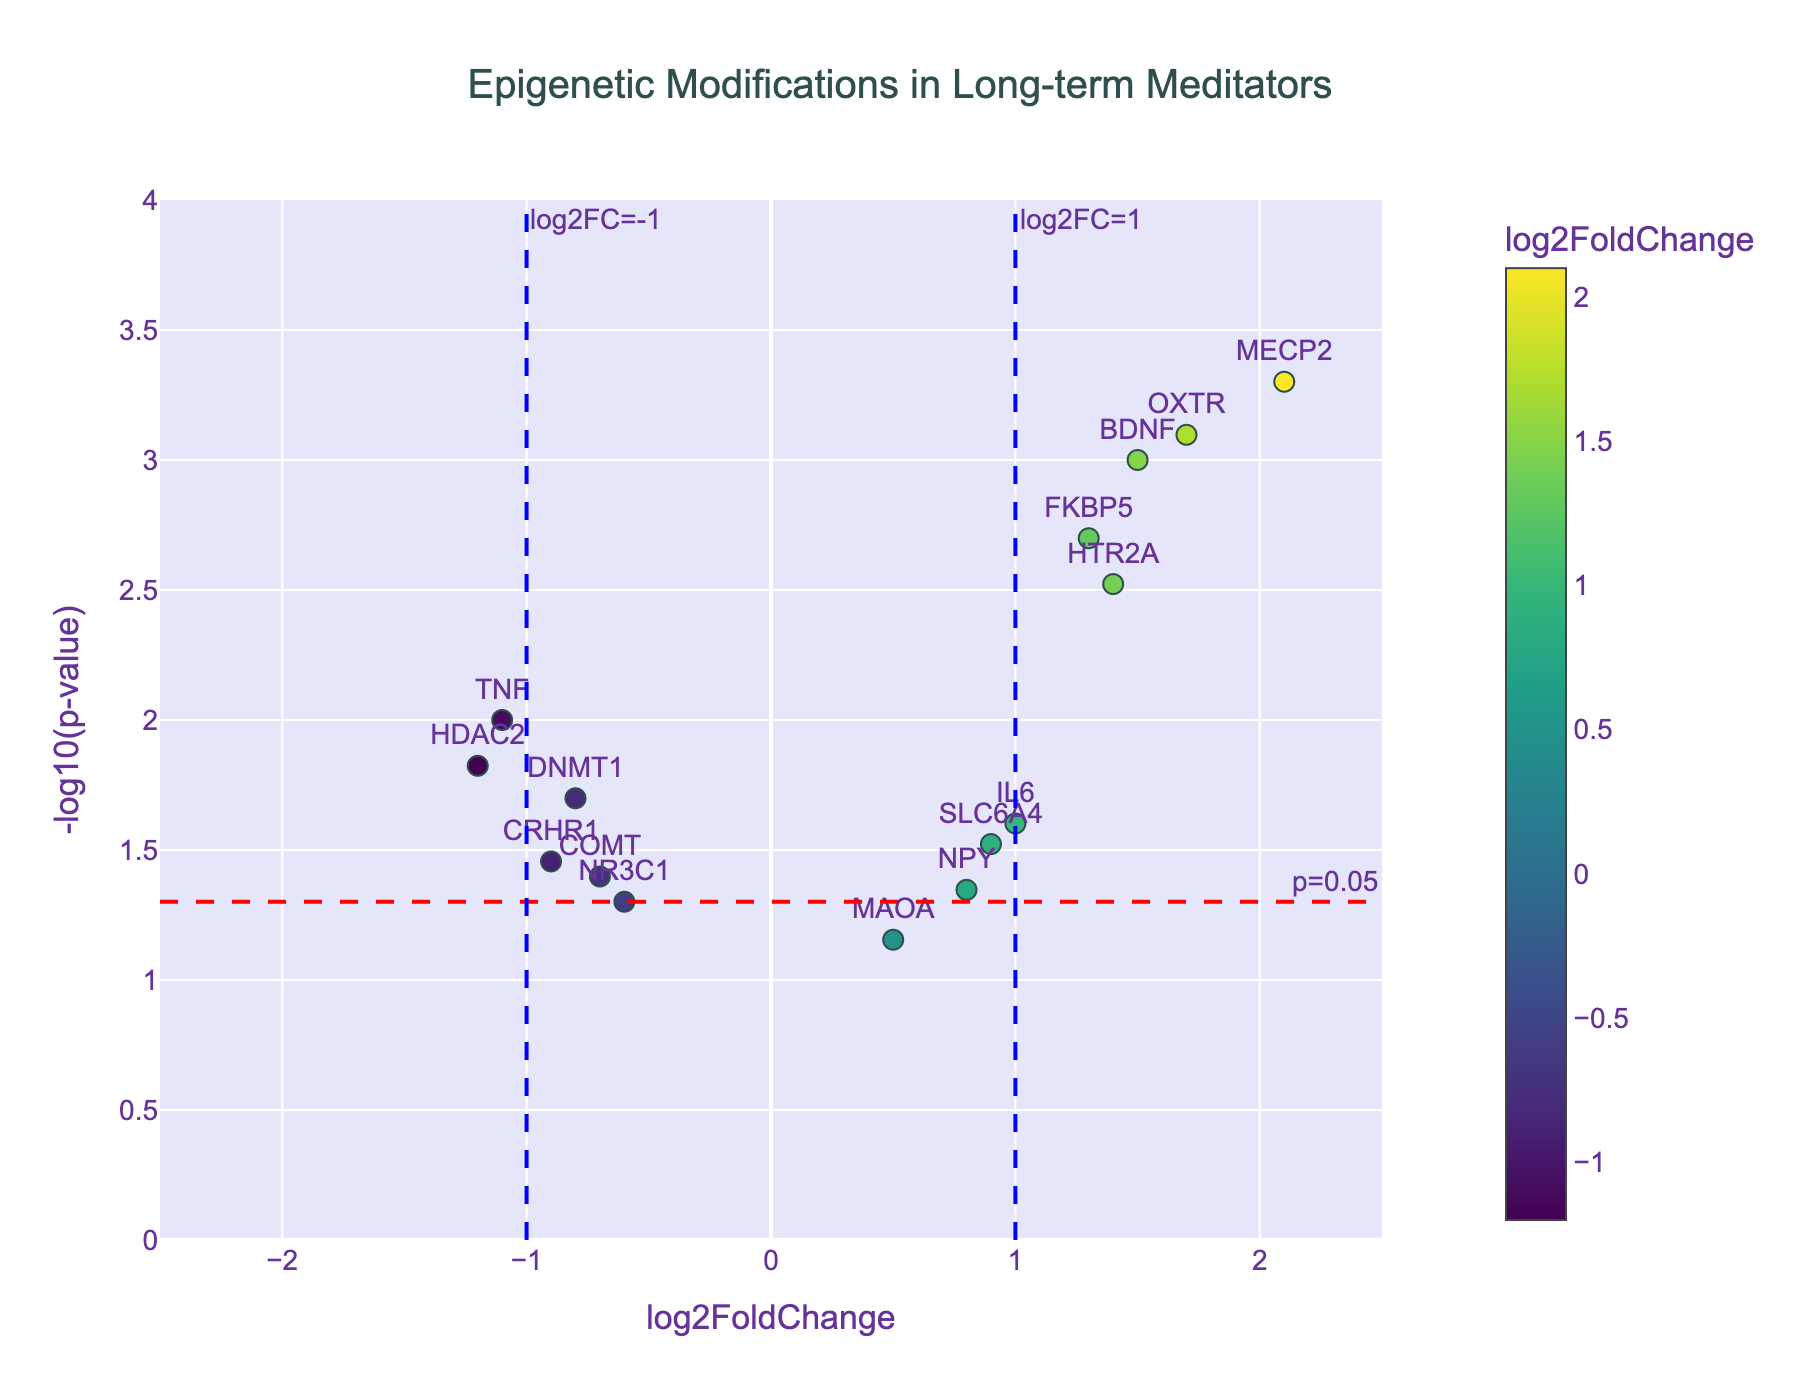What does the title of the plot indicate? The title "Epigenetic Modifications in Long-term Meditators" suggests that the plot is comparing the genetic expressions of long-term meditators to non-meditators, focusing on changes in epigenetic modifications.
Answer: Epigenetic Modifications in Long-term Meditators What are the units on the x-axis? The x-axis is labeled "log2FoldChange," indicating the fold change in gene expression levels between meditators and non-meditators on a logarithmic scale base 2.
Answer: log2FoldChange Which data point has the highest significance? The data point with the highest significance will have the largest -log10(p-value). "MECP2" has a -log10(p-value) higher than all other points in the plot.
Answer: MECP2 How many genes have a p-value less than 0.05? Look for the horizontal threshold line at y = -log10(0.05), which is approximately 1.3. Count all the points that are above this line. There are 11 such genes.
Answer: 11 Which genes have a log2FoldChange greater than 1 and are also significant (p < 0.05)? Look for points in the top right quadrant (right of the vertical blue line at x = 1 and above the horizontal red line at y = 1.3). These genes are "MECP2", "OXTR", "BDNF", "FKBP5", and "HTR2A".
Answer: MECP2, OXTR, BDNF, FKBP5, HTR2A What is the log2FoldChange value for the gene "SLC6A4"? Locate the gene "SLC6A4" on the plot and read its x-axis value, the log2FoldChange. For "SLC6A4", it is 0.9.
Answer: 0.9 Which gene has the lowest log2FoldChange but is still significant? Find the gene with the lowest log2FoldChange value (leftmost) that is above the horizontal red significance line (y > 1.3). "HDAC2" has the lowest log2FoldChange of -1.2 and p < 0.05.
Answer: HDAC2 How many genes have a log2FoldChange less than -1? Look at the left side of the vertical blue line at x = -1. Count the genes that are to the left of this line. There is one such gene, "HDAC2".
Answer: 1 Compare the log2FoldChange of "NR3C1" and "TNF". Which one shows a greater reduction in expression? Both "NR3C1" and "TNF" have negative log2FoldChange values. "TNF" has a log2FoldChange of -1.1 while "NR3C1" has -0.6. A more negative value indicates a greater reduction.
Answer: TNF What does the color gradient in the plot represent? The color gradient (Viridis colorscale) represents the log2FoldChange values. Darker colors signify lower changes while lighter colors indicate higher changes in gene expression levels.
Answer: log2FoldChange 